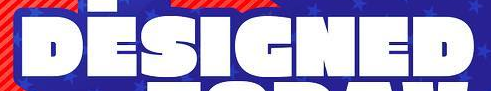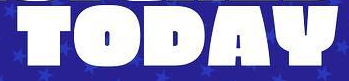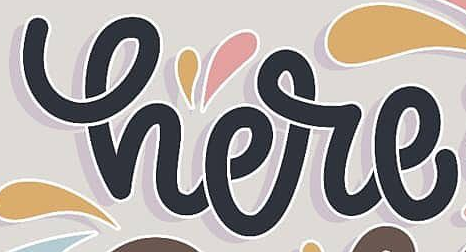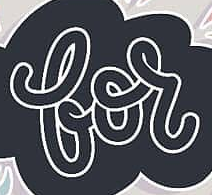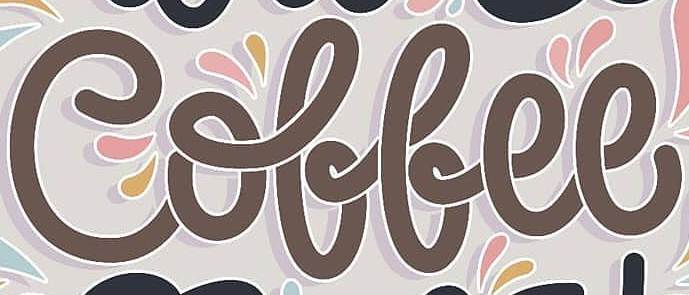Read the text content from these images in order, separated by a semicolon. DESIGNED; TODAY; here; for; Coffee 